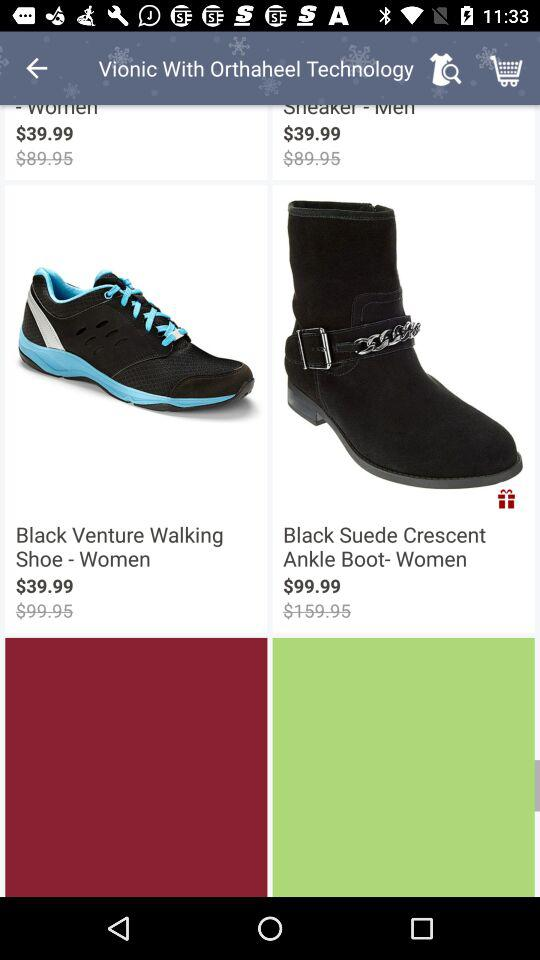What is the original price of "Black Venture Walking Shoe - Women"? The original price of the "Black Venture Walking Shoe - Women" is $99.45. 